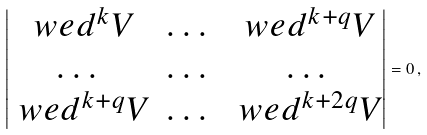<formula> <loc_0><loc_0><loc_500><loc_500>\begin{vmatrix} \ w e d ^ { k } V & \dots & \ w e d ^ { k + q } V \\ \dots & \dots & \dots \\ \ w e d ^ { k + q } V & \dots & \ w e d ^ { k + 2 q } V \\ \end{vmatrix} = 0 \, ,</formula> 